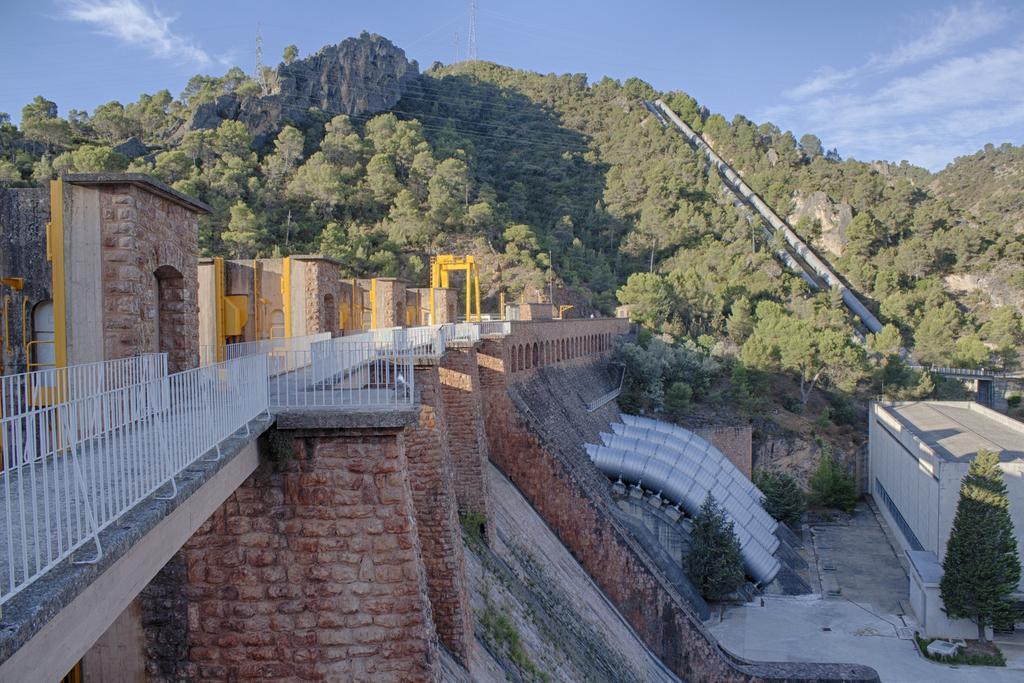Please provide a concise description of this image. In this picture it looks like dam and we can see shelters, shed, trees, bridge, railings, hills and pipes. In the background of the image we can see the sky. 